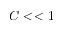<formula> <loc_0><loc_0><loc_500><loc_500>C < < 1</formula> 